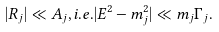<formula> <loc_0><loc_0><loc_500><loc_500>| R _ { j } | \ll A _ { j } , i . e . | E ^ { 2 } - m _ { j } ^ { 2 } | \ll m _ { j } \Gamma _ { j } .</formula> 